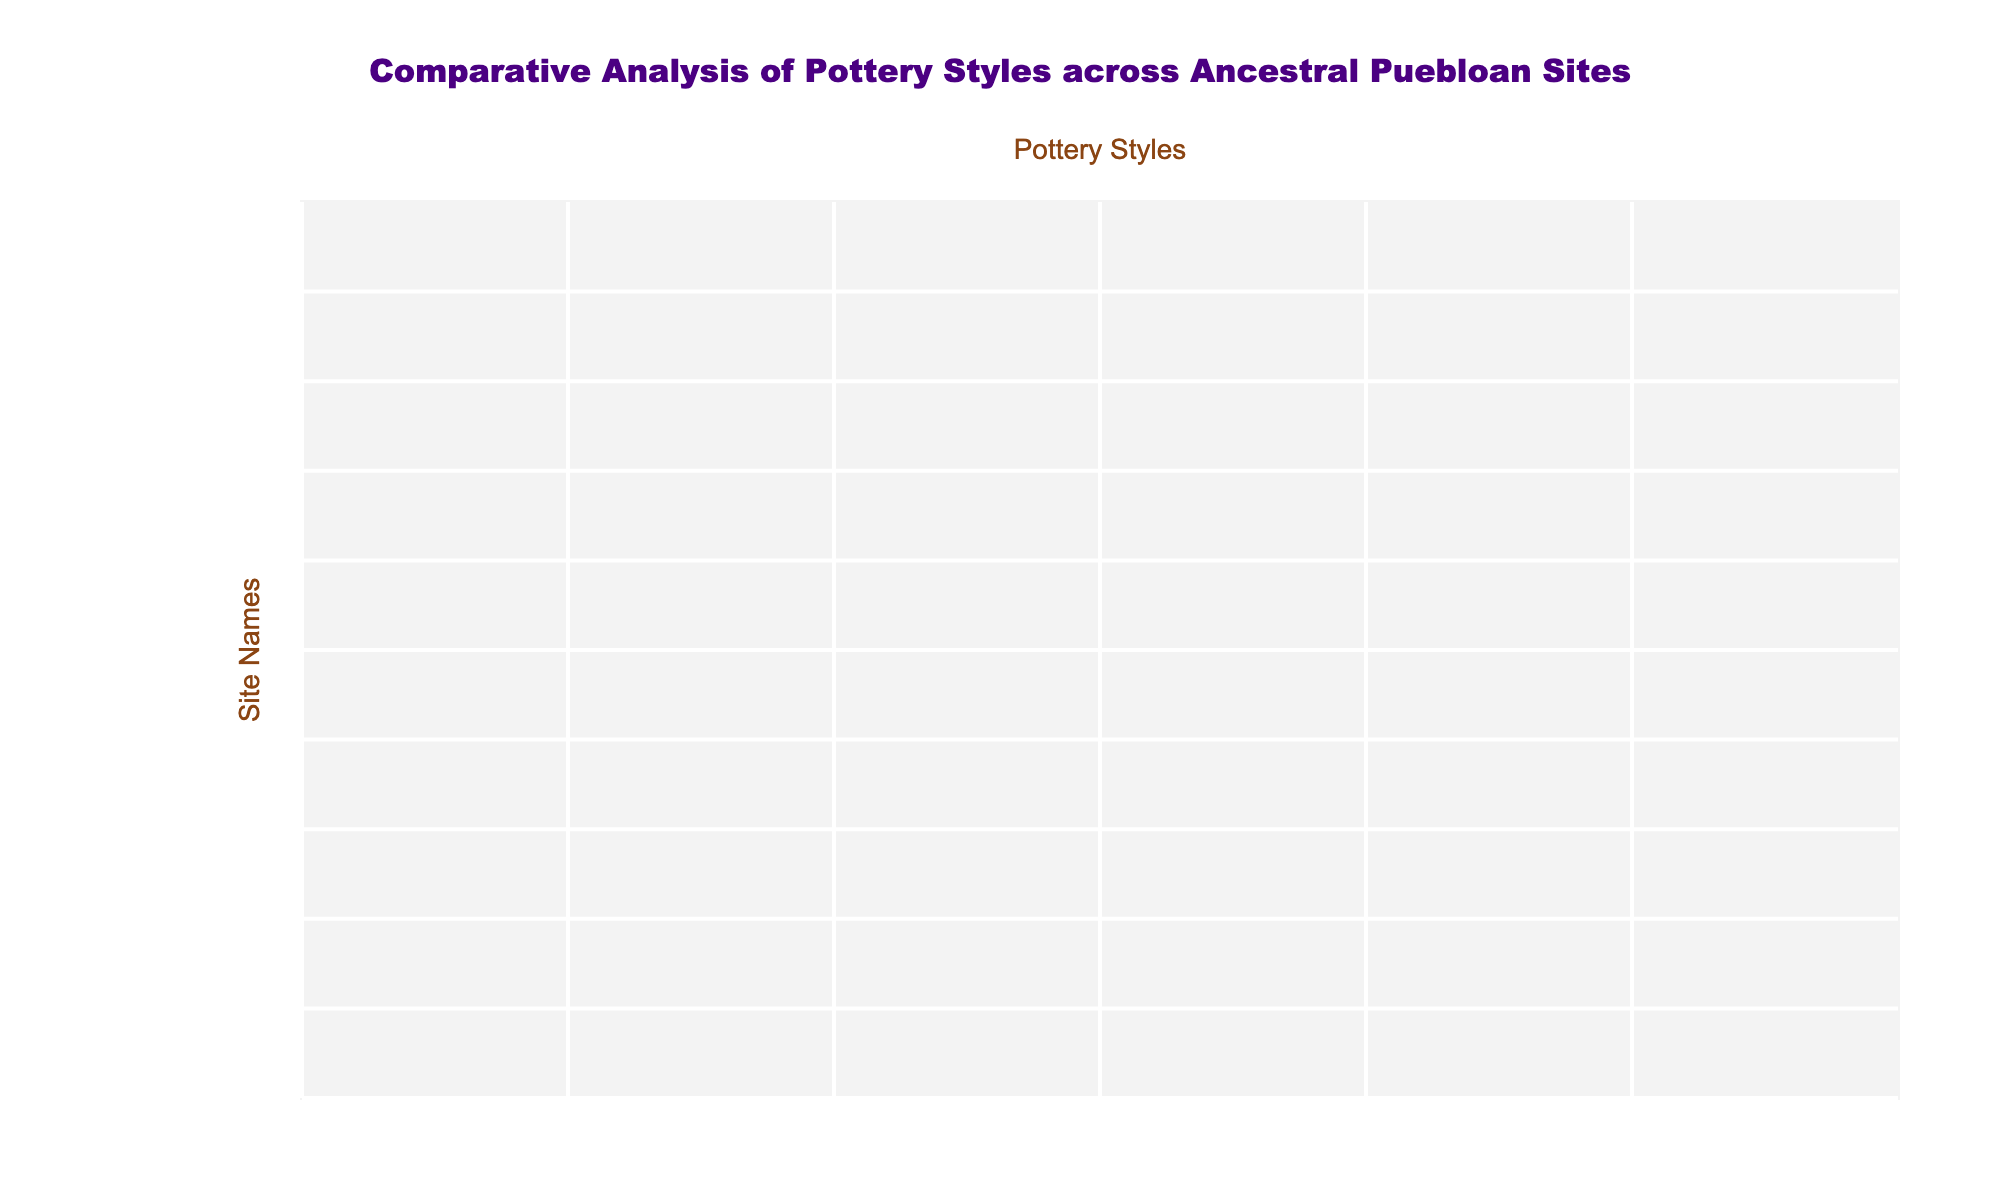What is the highest rated pottery style in Chaco Canyon? In the Chaco Canyon row, the highest rating is "Very High" for both Mesa Verde Black-on-white and Chaco Black-on-white pottery styles.
Answer: Mesa Verde Black-on-white, Chaco Black-on-white Which site has a "Very High" rating for Santa Fe Black-on-white pottery? Looking at the Santa Fe Black-on-white column, the only site with a rating of "Very High" is Pecos Pueblo.
Answer: Pecos Pueblo What is the average rating for Kiva Pottery across all sites? The ratings for Kiva Pottery are: High, Medium, Low, Medium, Low, Very Low, Very Low, Low, Medium, Low. Converting to numerical values (Very Low=1, Low=2, Medium=3, High=4, Very High=5), we get (4 + 3 + 2 + 3 + 2 + 1 + 1 + 2 + 3 + 1) = 22. There are 10 data points, so the average is 22/10 = 2.2, corresponding to a "Low" rating.
Answer: Low Which pottery style has the lowest overall rating across all sites? Analyzing the ratings across all sites, Rio Grande Glaze Ware has a consistent rating of "Very Low" for several sites, including Chaco Canyon, Aztec Ruins, Gila Cliff Dwellings, and Pecos Pueblo. This indicates it has the lowest overall prominence.
Answer: Rio Grande Glaze Ware Is Gila Cliff Dwellings rated higher in Mesa Verde Black-on-white or Rio Grande Glaze Ware? In Gila Cliff Dwellings, the rating for Mesa Verde Black-on-white is "Low" and for Rio Grande Glaze Ware is "Low" as well. Therefore, both ratings are the same.
Answer: No How many sites have a "Medium" rating for Chaco Black-on-white pottery? By examining the Chaco Black-on-white column, the sites with a "Medium" rating are Salmon Ruins and Pottery Mound. Therefore, there are 2 sites with this rating.
Answer: 2 Which pottery style has the highest total count of "Very High" ratings across all sites? By reviewing the table for "Very High" ratings, Mesa Verde Black-on-white has 4, while Chaco Black-on-white has 2, Santa Fe Black-on-white has 2, and others have lower counts. Thus, Mesa Verde Black-on-white has the highest count.
Answer: Mesa Verde Black-on-white Are there more sites with a "Low" rating in Kiva Pottery or Gila Cliff Dwellings pottery? Kiva Pottery has 4 sites with a "Low" rating (Bandelier, Gila Cliff Dwellings, Pecos Pueblo, Taos Pueblo) while Gila Cliff Dwellings pottery has only 1 "Low" rating (Gila Cliff Dwellings). Hence, Kiva Pottery has more sites rated "Low".
Answer: Kiva Pottery Which two pottery styles have the highest combined ratings of "High" and "Very High"? Upon calculating: Mesa Verde Black-on-white has 4 ("High" + "Very High"), and Chaco Black-on-white has 3. Combining their ratings gives a total of 7. This indicates that these two styles collectively have the best overall ratings.
Answer: Mesa Verde Black-on-white and Chaco Black-on-white What is the pottery style with the second highest rating in Salmon Ruins? In the Salmon Ruins row, the highest is "High" for Mesa Verde Black-on-white, and the second highest is "Medium" for Chaco Black-on-white.
Answer: Chaco Black-on-white 